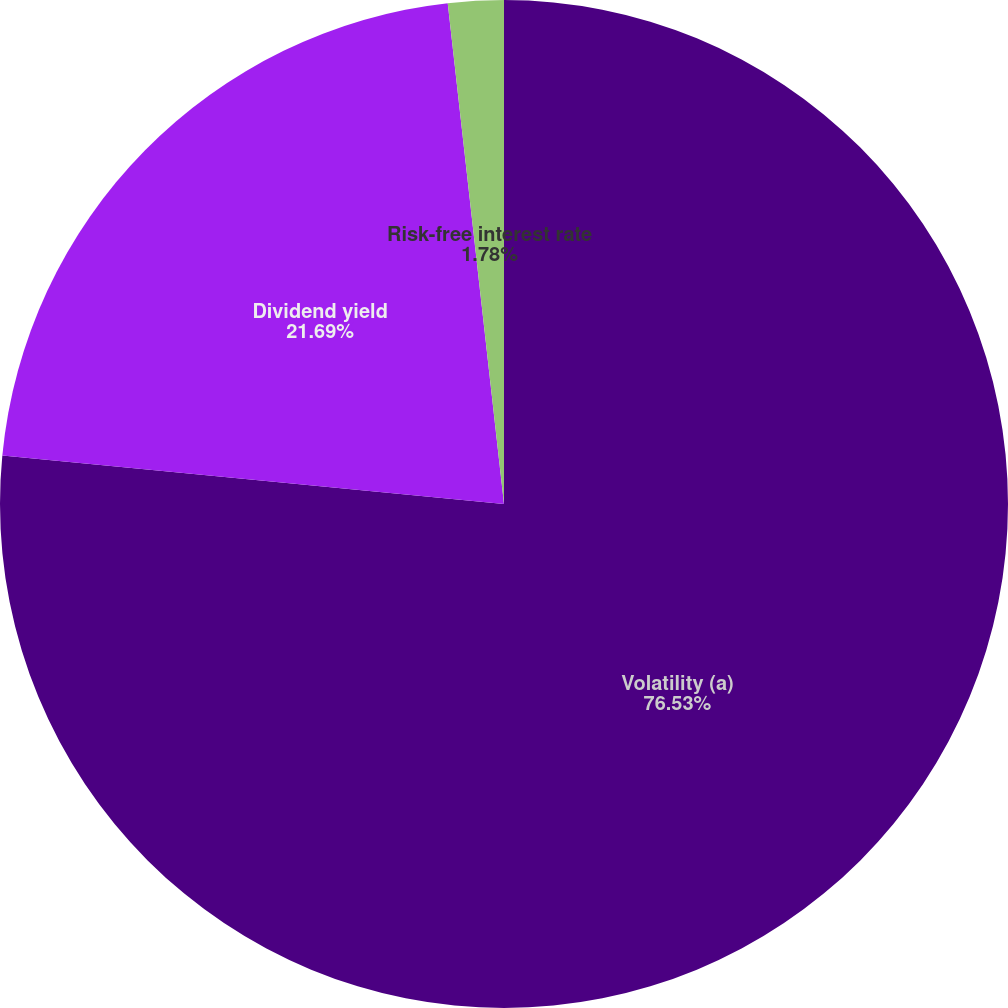<chart> <loc_0><loc_0><loc_500><loc_500><pie_chart><fcel>Volatility (a)<fcel>Dividend yield<fcel>Risk-free interest rate<nl><fcel>76.53%<fcel>21.69%<fcel>1.78%<nl></chart> 